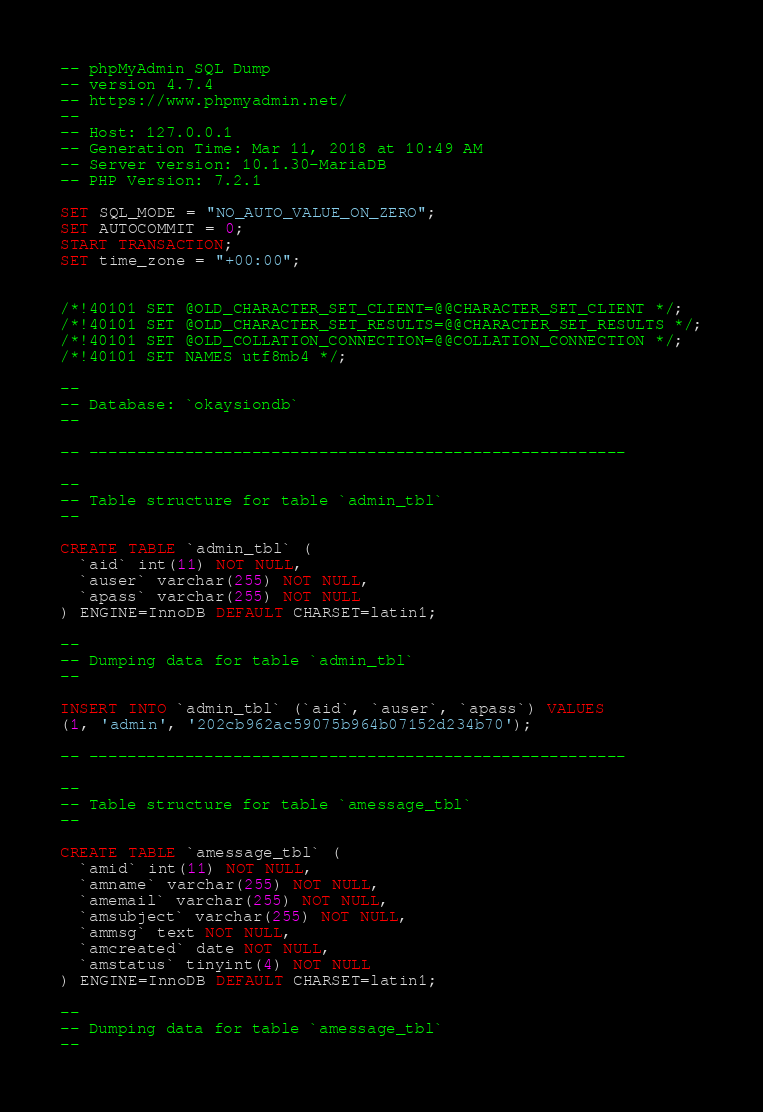Convert code to text. <code><loc_0><loc_0><loc_500><loc_500><_SQL_>-- phpMyAdmin SQL Dump
-- version 4.7.4
-- https://www.phpmyadmin.net/
--
-- Host: 127.0.0.1
-- Generation Time: Mar 11, 2018 at 10:49 AM
-- Server version: 10.1.30-MariaDB
-- PHP Version: 7.2.1

SET SQL_MODE = "NO_AUTO_VALUE_ON_ZERO";
SET AUTOCOMMIT = 0;
START TRANSACTION;
SET time_zone = "+00:00";


/*!40101 SET @OLD_CHARACTER_SET_CLIENT=@@CHARACTER_SET_CLIENT */;
/*!40101 SET @OLD_CHARACTER_SET_RESULTS=@@CHARACTER_SET_RESULTS */;
/*!40101 SET @OLD_COLLATION_CONNECTION=@@COLLATION_CONNECTION */;
/*!40101 SET NAMES utf8mb4 */;

--
-- Database: `okaysiondb`
--

-- --------------------------------------------------------

--
-- Table structure for table `admin_tbl`
--

CREATE TABLE `admin_tbl` (
  `aid` int(11) NOT NULL,
  `auser` varchar(255) NOT NULL,
  `apass` varchar(255) NOT NULL
) ENGINE=InnoDB DEFAULT CHARSET=latin1;

--
-- Dumping data for table `admin_tbl`
--

INSERT INTO `admin_tbl` (`aid`, `auser`, `apass`) VALUES
(1, 'admin', '202cb962ac59075b964b07152d234b70');

-- --------------------------------------------------------

--
-- Table structure for table `amessage_tbl`
--

CREATE TABLE `amessage_tbl` (
  `amid` int(11) NOT NULL,
  `amname` varchar(255) NOT NULL,
  `amemail` varchar(255) NOT NULL,
  `amsubject` varchar(255) NOT NULL,
  `ammsg` text NOT NULL,
  `amcreated` date NOT NULL,
  `amstatus` tinyint(4) NOT NULL
) ENGINE=InnoDB DEFAULT CHARSET=latin1;

--
-- Dumping data for table `amessage_tbl`
--
</code> 